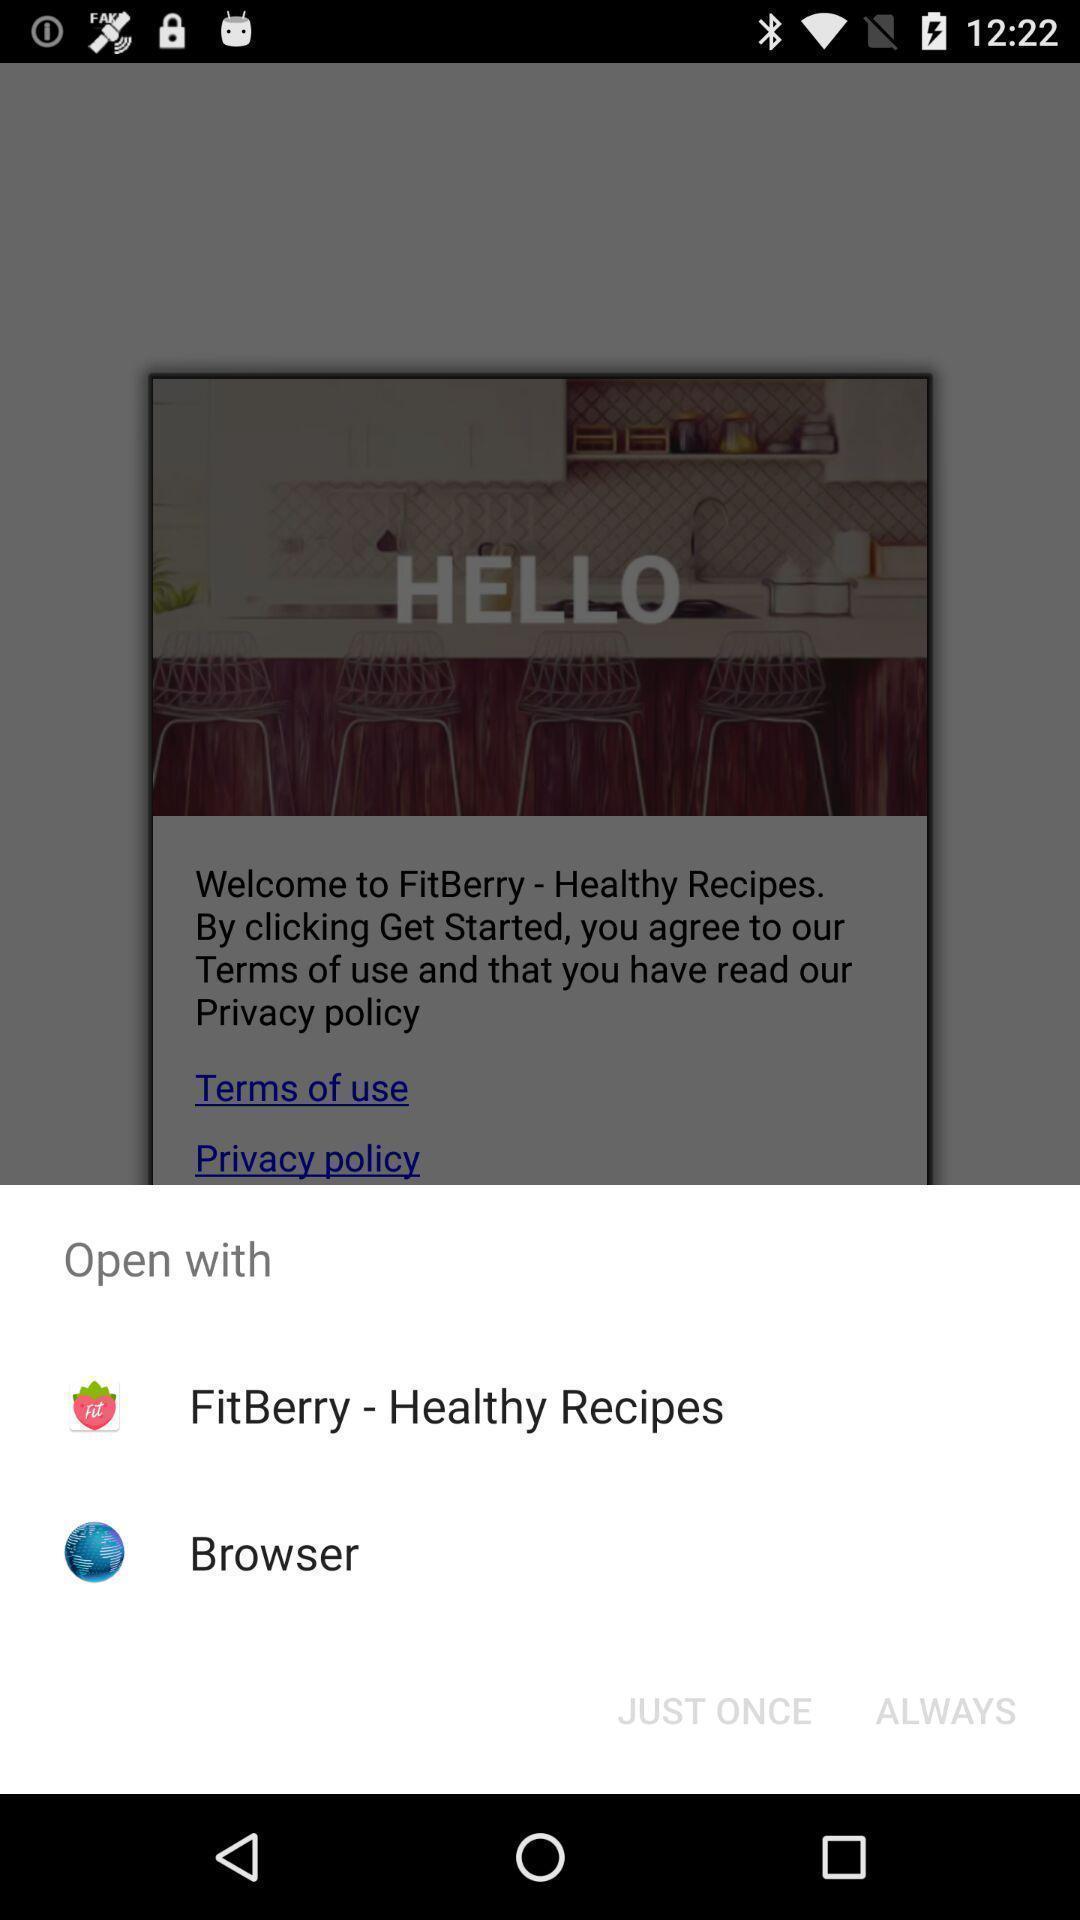Provide a detailed account of this screenshot. Popup showing different options to open the recipes. 